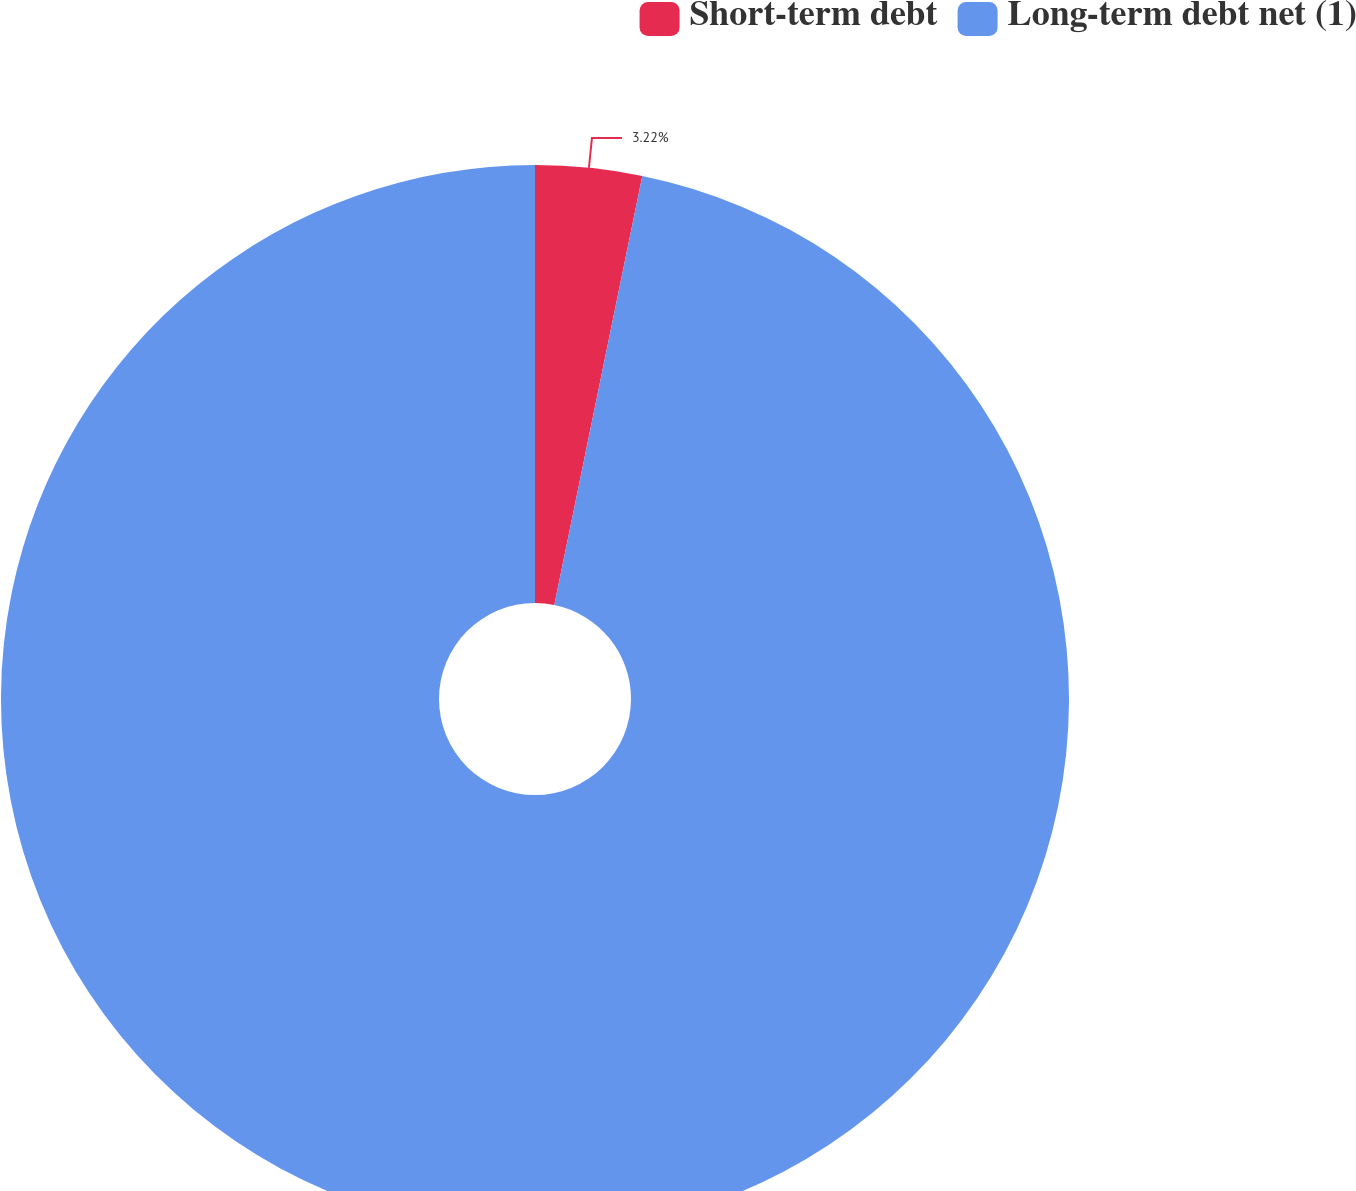Convert chart to OTSL. <chart><loc_0><loc_0><loc_500><loc_500><pie_chart><fcel>Short-term debt<fcel>Long-term debt net (1)<nl><fcel>3.22%<fcel>96.78%<nl></chart> 